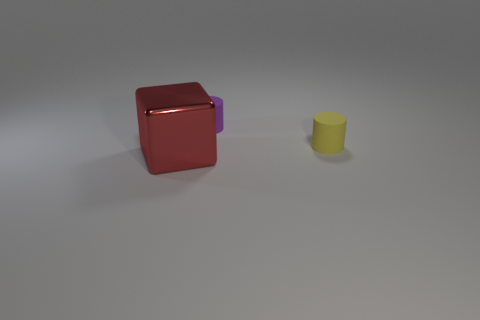What shape is the rubber object on the right side of the tiny rubber thing left of the object on the right side of the small purple matte cylinder?
Offer a very short reply. Cylinder. Do the small object left of the tiny yellow matte cylinder and the object in front of the tiny yellow matte cylinder have the same material?
Your response must be concise. No. The rubber thing in front of the purple matte thing has what shape?
Give a very brief answer. Cylinder. Is the number of small brown rubber cubes less than the number of big red blocks?
Provide a succinct answer. Yes. Is there a matte cylinder to the left of the small object that is in front of the purple matte cylinder that is behind the yellow cylinder?
Provide a short and direct response. Yes. How many metallic things are big brown balls or red things?
Offer a terse response. 1. There is a yellow rubber cylinder; how many large things are to the right of it?
Keep it short and to the point. 0. How many things are both right of the big shiny thing and to the left of the purple cylinder?
Your answer should be very brief. 0. The small yellow thing that is made of the same material as the tiny purple thing is what shape?
Make the answer very short. Cylinder. Is the size of the cylinder that is on the right side of the purple rubber cylinder the same as the object that is on the left side of the purple rubber object?
Your response must be concise. No. 